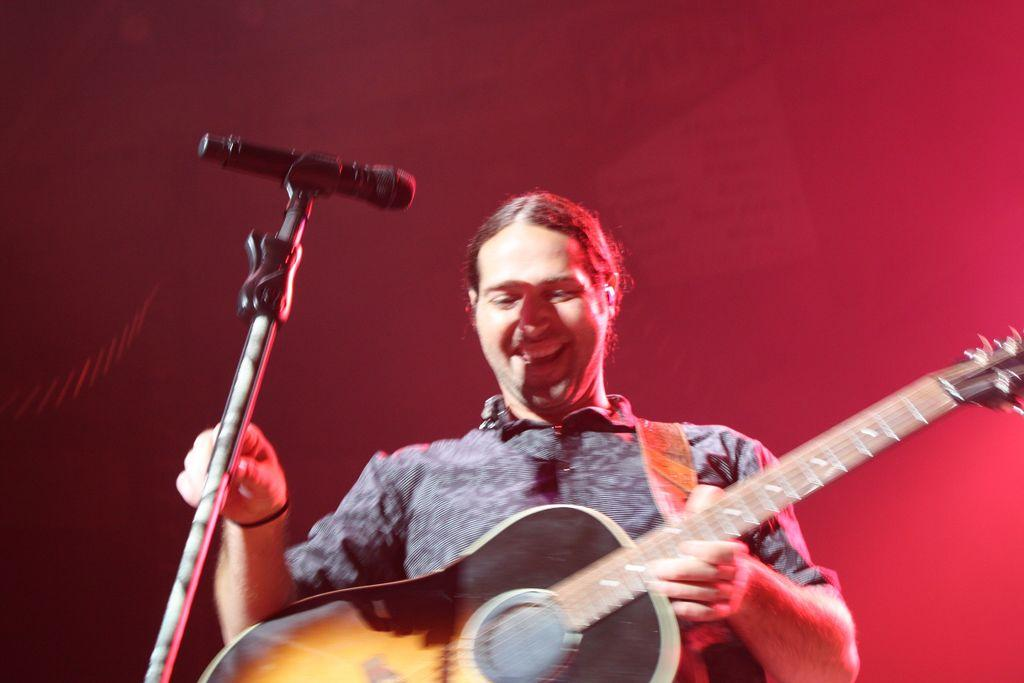What is the man holding in his left hand in the image? The man is holding a guitar in his left hand. What is the man holding in his right hand in the image? The man is holding a mic holder with a mic in his right hand. What is the man's facial expression in the image? The man is smiling in the image. What type of education does the fireman receive in the image? There is no fireman or education present in the image; it features a man holding a guitar and a mic holder with a mic. What is the man learning in the image? There is no indication in the image that the man is learning anything. 